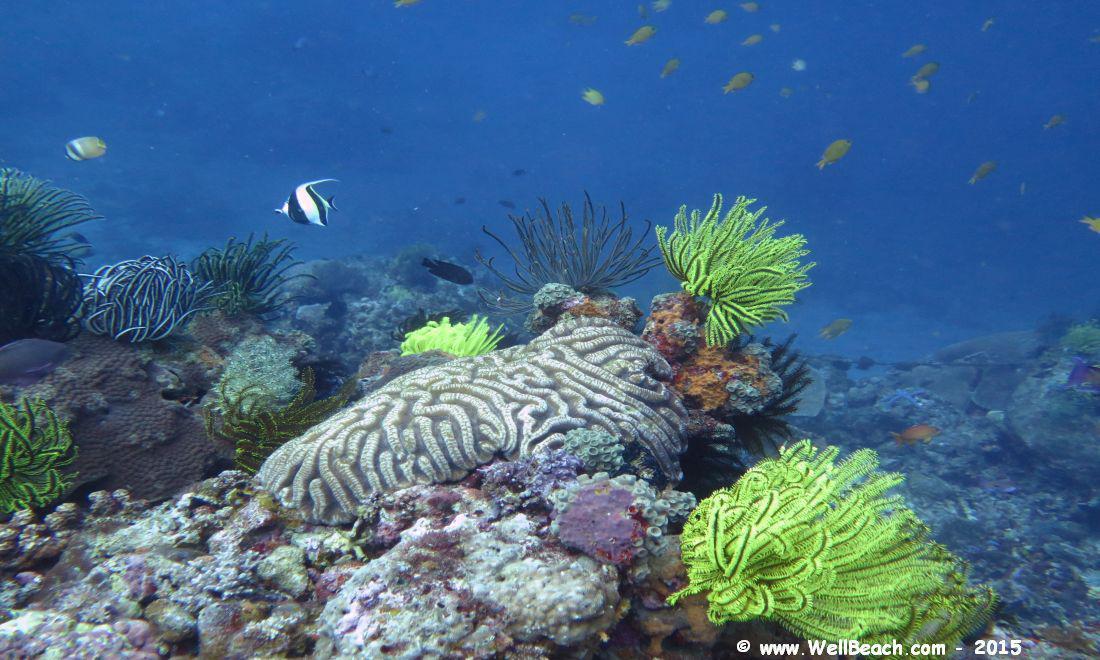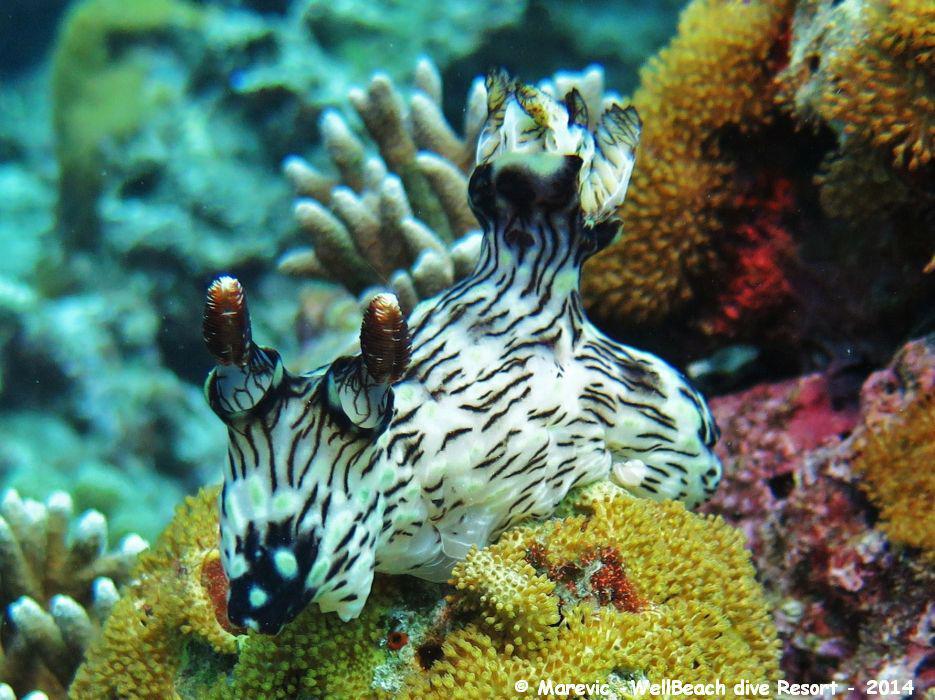The first image is the image on the left, the second image is the image on the right. Examine the images to the left and right. Is the description "The right image contains some creature with black and white stripes and with two antenna-type horns and something flower-like sprouting from its back." accurate? Answer yes or no. Yes. The first image is the image on the left, the second image is the image on the right. Examine the images to the left and right. Is the description "A white and black striped fish is swimming in the water in the image on the right." accurate? Answer yes or no. No. 